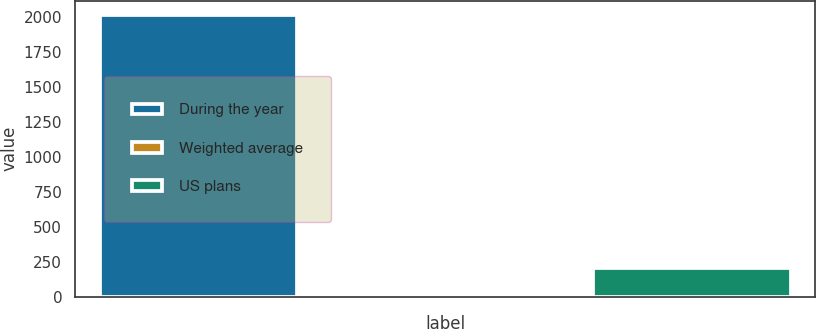<chart> <loc_0><loc_0><loc_500><loc_500><bar_chart><fcel>During the year<fcel>Weighted average<fcel>US plans<nl><fcel>2014<fcel>5.6<fcel>206.44<nl></chart> 